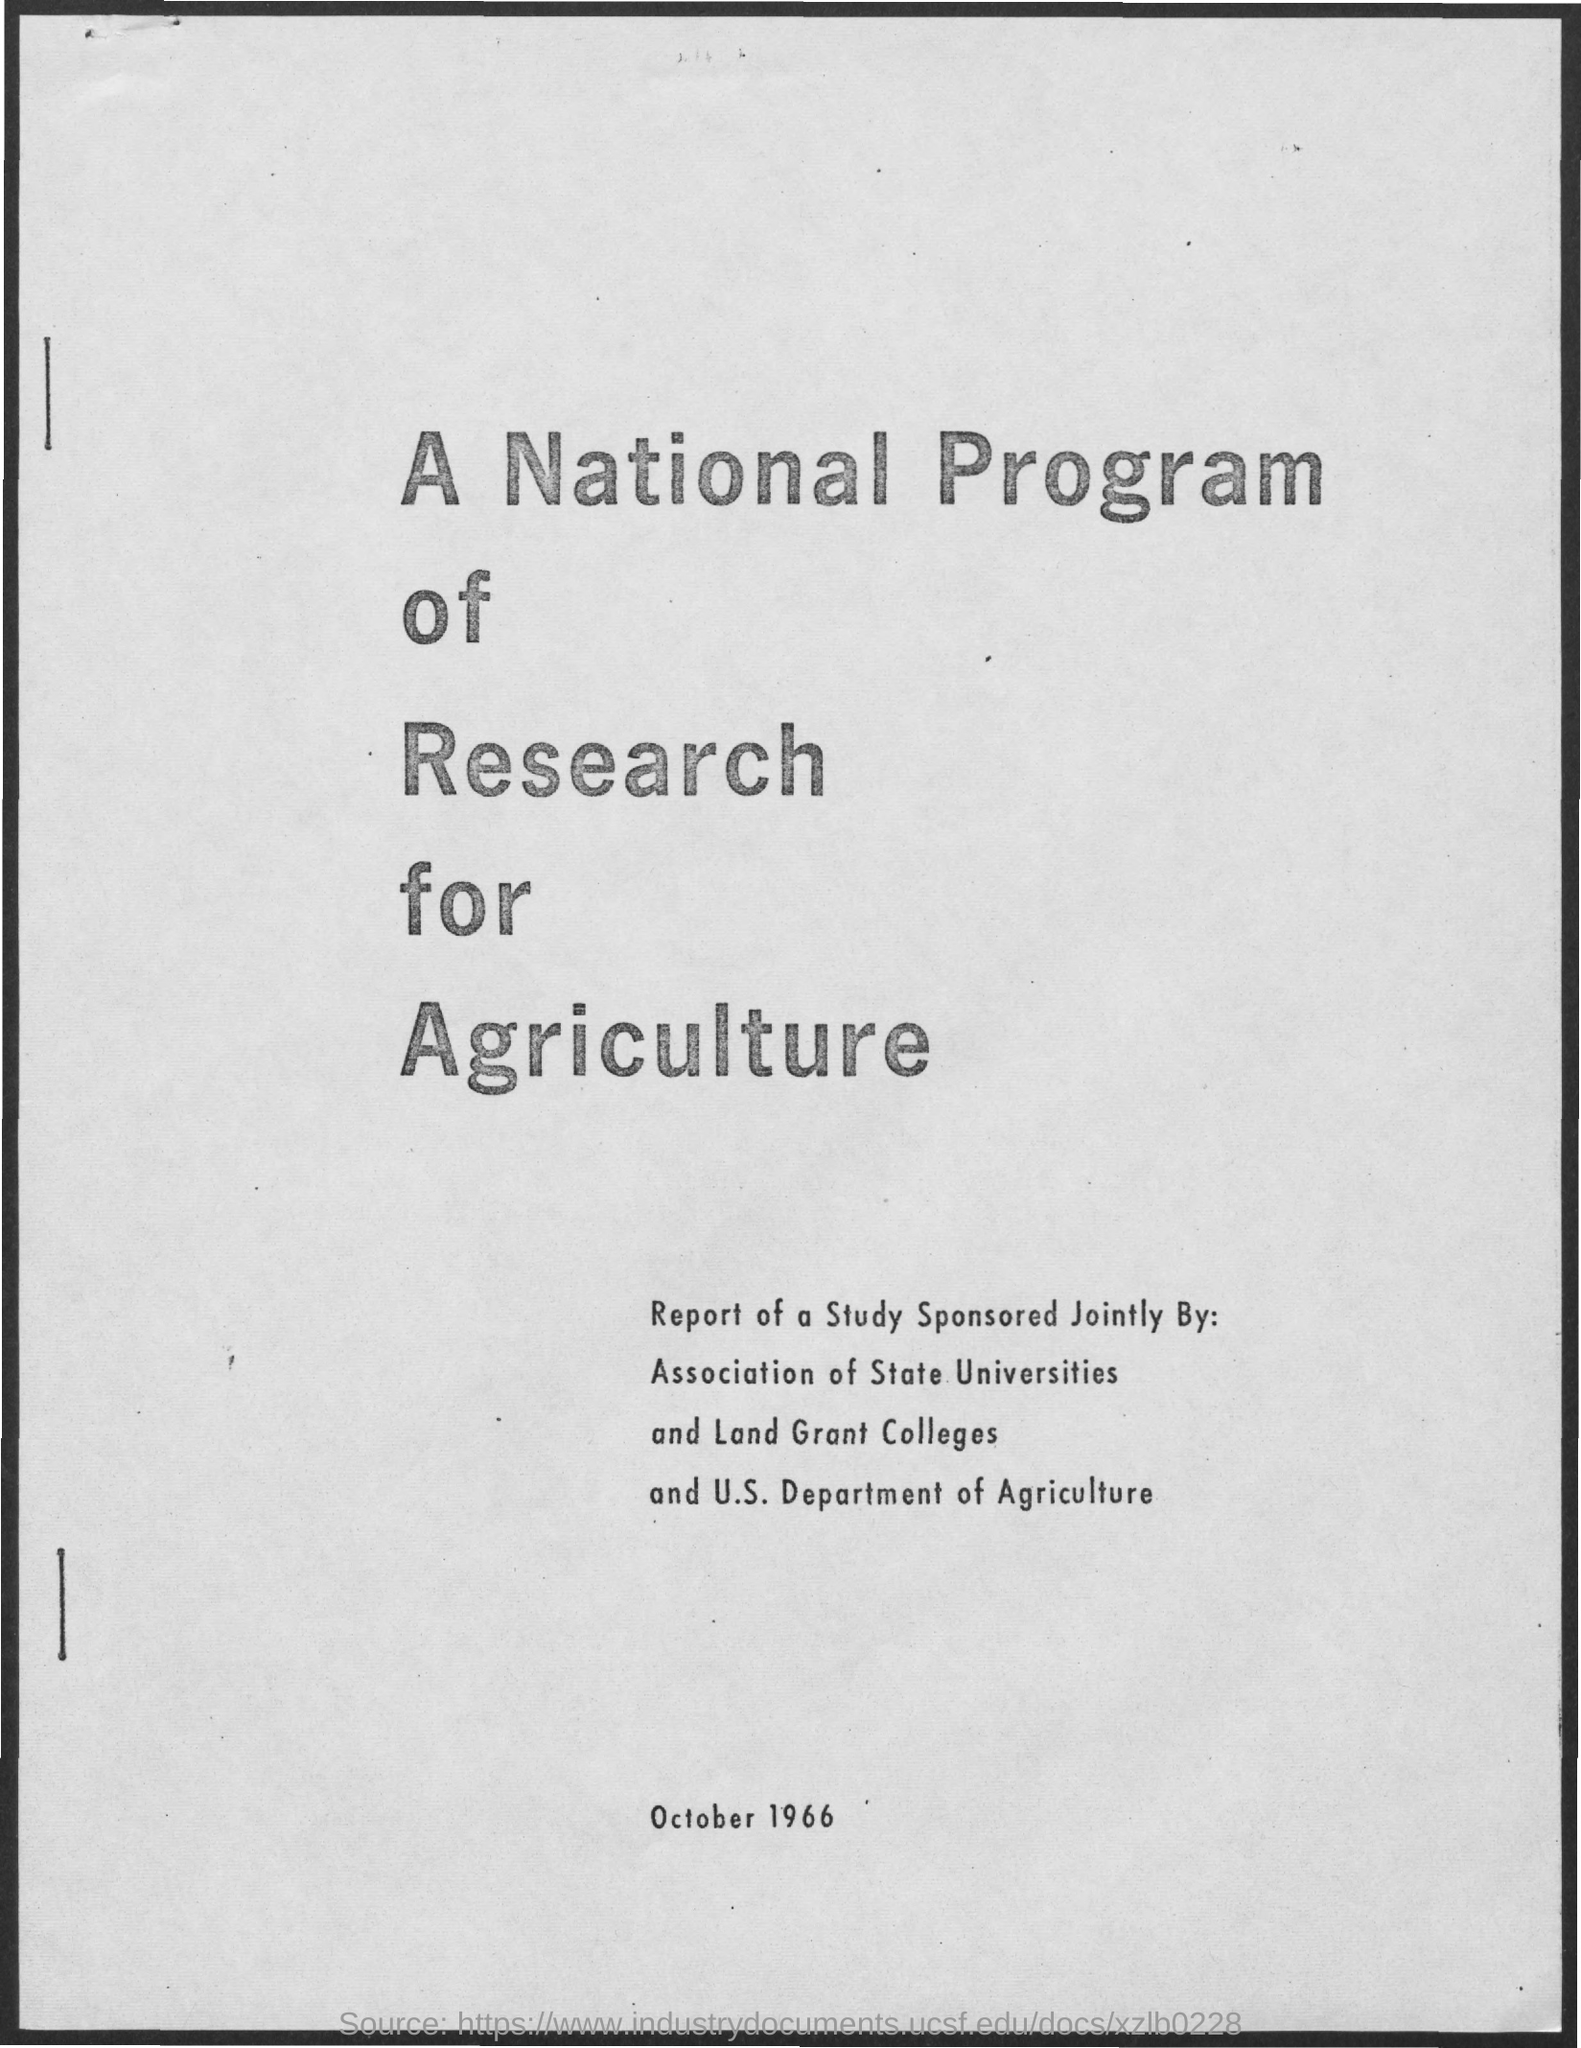What is the date on the document?
Make the answer very short. October 1966. 